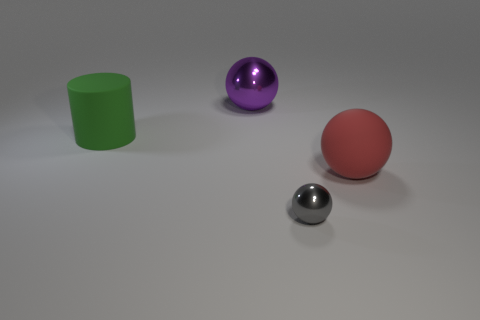Subtract all purple balls. How many balls are left? 2 Subtract 1 spheres. How many spheres are left? 2 Add 2 gray metal spheres. How many objects exist? 6 Subtract all cyan spheres. Subtract all brown cylinders. How many spheres are left? 3 Subtract all spheres. How many objects are left? 1 Subtract 0 brown cylinders. How many objects are left? 4 Subtract all small metal things. Subtract all tiny objects. How many objects are left? 2 Add 1 purple balls. How many purple balls are left? 2 Add 1 large green things. How many large green things exist? 2 